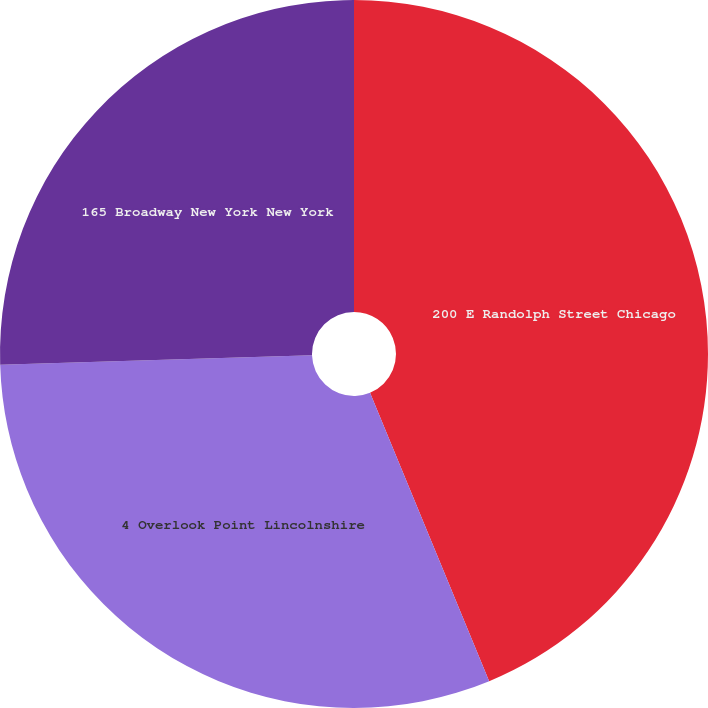Convert chart. <chart><loc_0><loc_0><loc_500><loc_500><pie_chart><fcel>200 E Randolph Street Chicago<fcel>4 Overlook Point Lincolnshire<fcel>165 Broadway New York New York<nl><fcel>43.76%<fcel>30.75%<fcel>25.48%<nl></chart> 